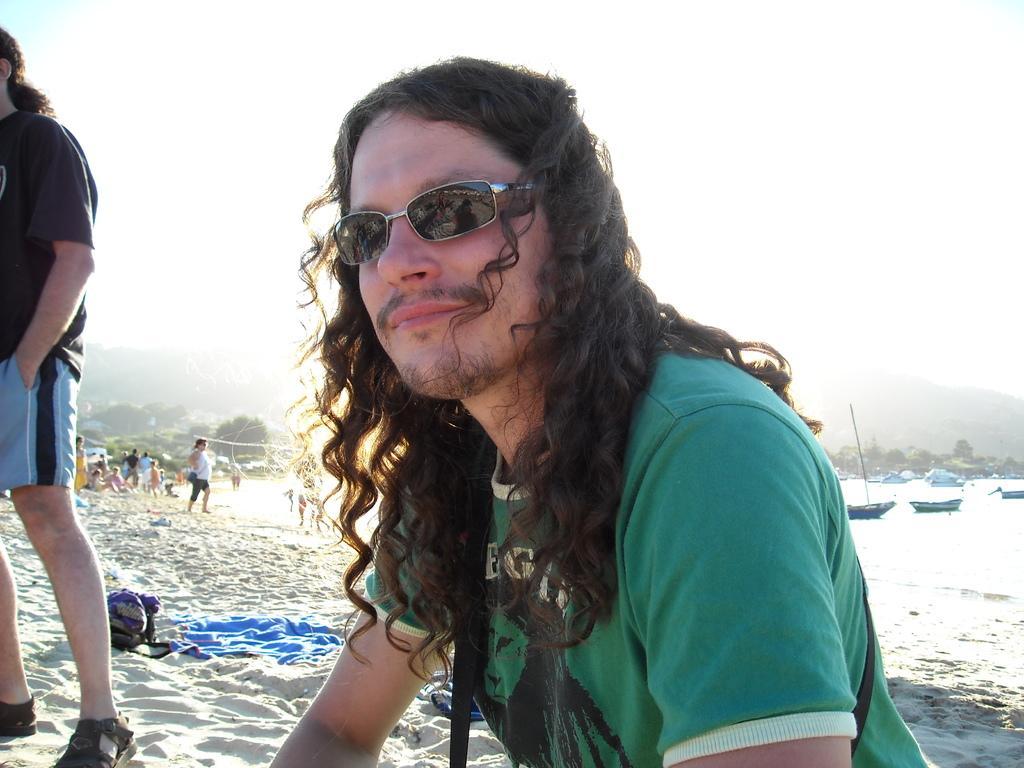In one or two sentences, can you explain what this image depicts? There is a person in the center of the image and there are boats on the water surface, greenery, it seems like mountains and sky in the background are, there is a towel and a bag on the sand. 